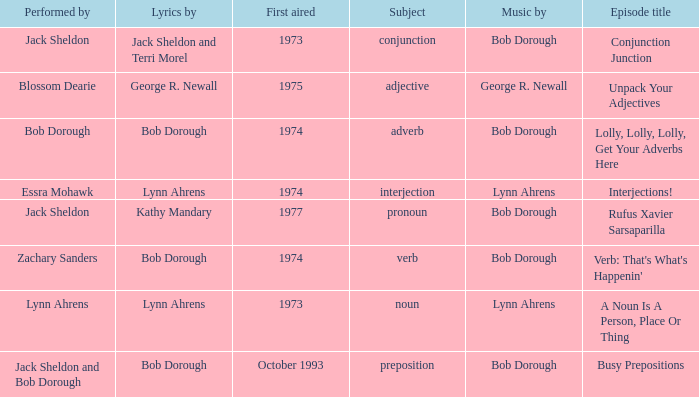When zachary sanders is the performer how many people is the music by? 1.0. 